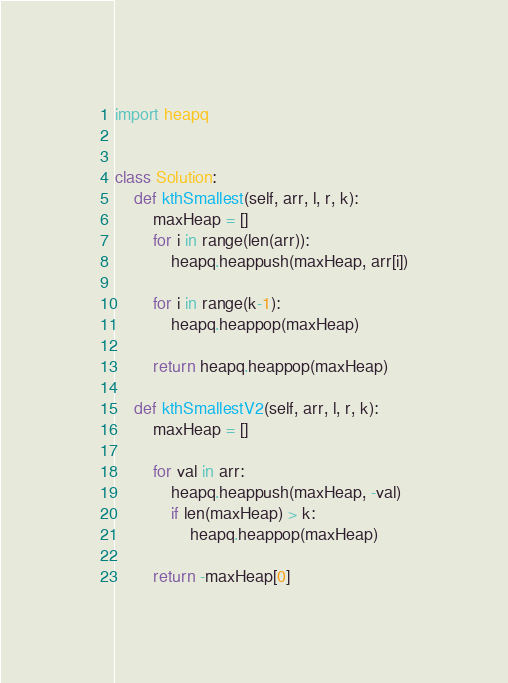<code> <loc_0><loc_0><loc_500><loc_500><_Python_>import heapq


class Solution:
    def kthSmallest(self, arr, l, r, k):
        maxHeap = []
        for i in range(len(arr)):
            heapq.heappush(maxHeap, arr[i])

        for i in range(k-1):
            heapq.heappop(maxHeap)

        return heapq.heappop(maxHeap)

    def kthSmallestV2(self, arr, l, r, k):
        maxHeap = []

        for val in arr:
            heapq.heappush(maxHeap, -val)
            if len(maxHeap) > k:
                heapq.heappop(maxHeap)

        return -maxHeap[0]

</code> 